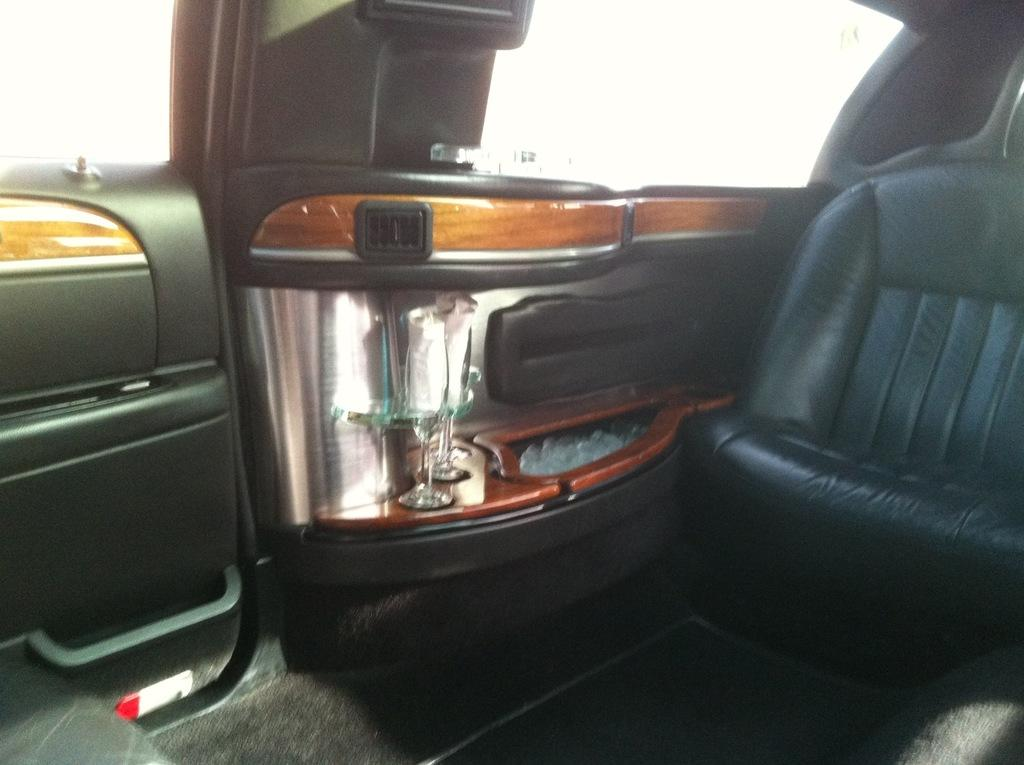What type of location is depicted in the image? The image is an inside view of a vehicle. What can be found inside the vehicle? There is a seat in the vehicle. How can passengers enter or exit the vehicle? There are side doors in the vehicle. What objects are placed on the side door platform? There are glasses on the side door platform. What type of trees can be seen through the windows of the vehicle in the image? There are no trees visible in the image, as it is an inside view of a vehicle. What kind of marble is used for the flooring in the vehicle? There is no marble present in the image; it is an inside view of a vehicle with a seat, side doors, and glasses on the side door platform. 